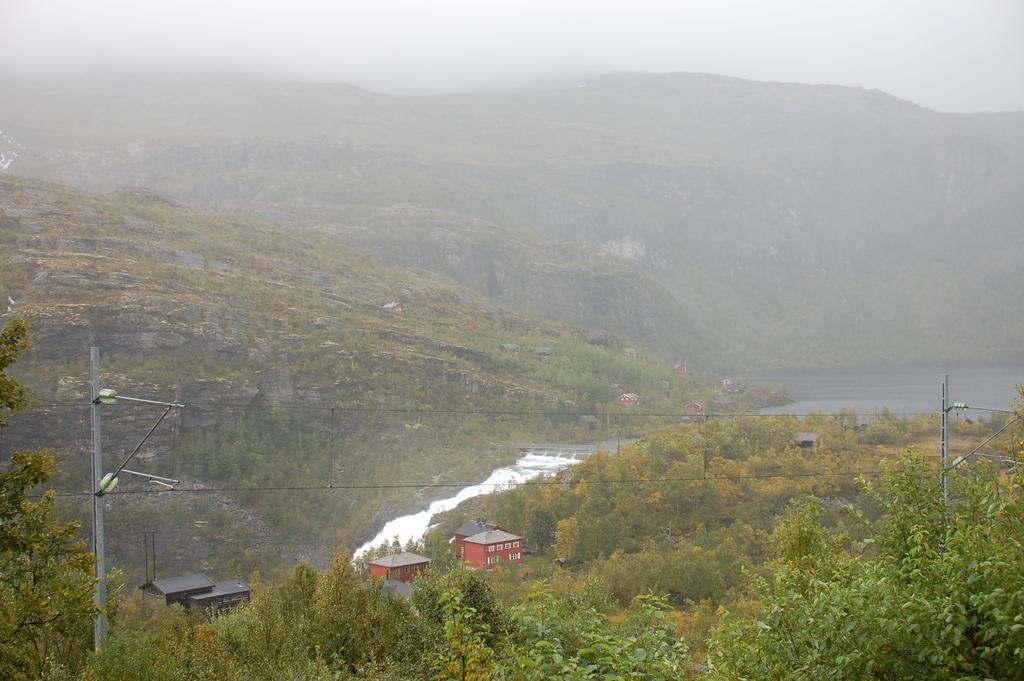What is the tall structure in the image? There is an electric pole in the image. What is connected to the electric pole? There are electric wires in the image. What type of man-made structures can be seen in the image? There are buildings in the image. What natural feature is present in the image? There is a river in the image. What type of vegetation is in the image? There is a tree in the image. What type of geographical feature is in the image? There are mountains in the image. What atmospheric condition is present in the image? There is fog in the image. What part of the natural environment is visible in the image? The sky is visible in the image. What type of plastic detail can be seen on the electric pole in the image? There is no plastic detail present on the electric pole in the image. What type of chain is hanging from the tree in the image? There is no chain hanging from the tree in the image. 